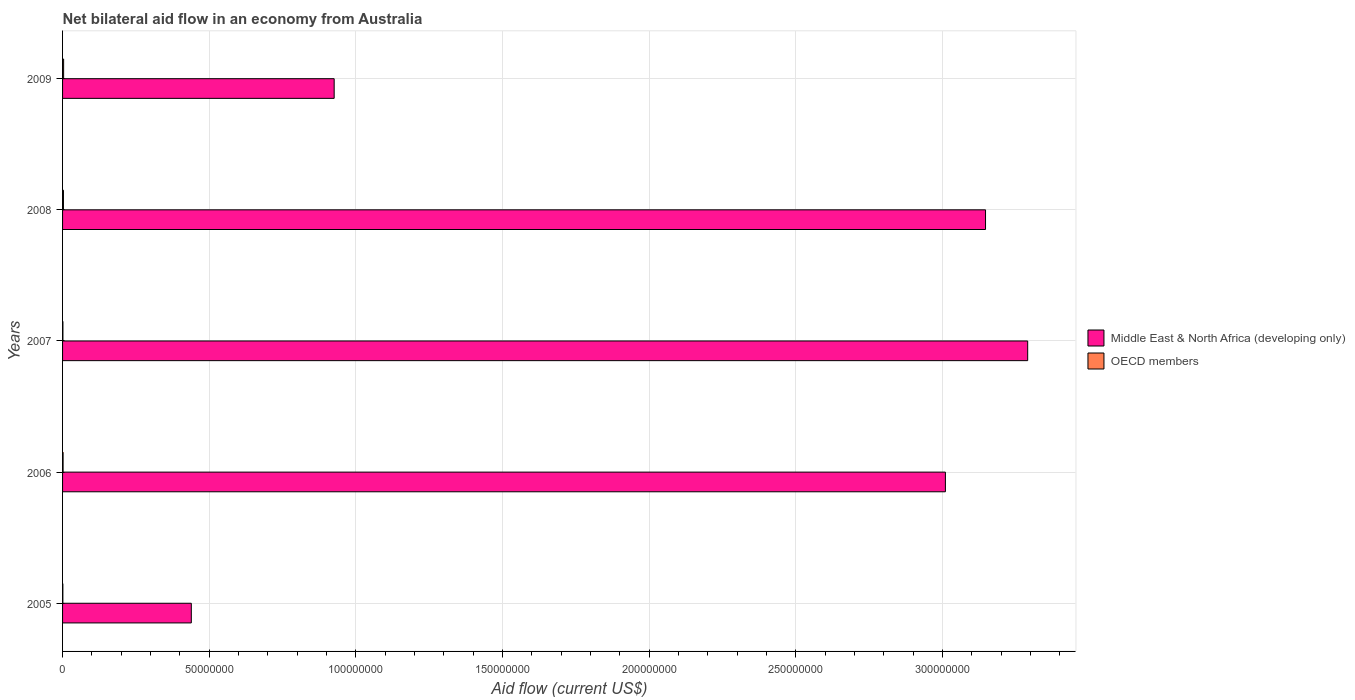Are the number of bars per tick equal to the number of legend labels?
Your response must be concise. Yes. Are the number of bars on each tick of the Y-axis equal?
Keep it short and to the point. Yes. In how many cases, is the number of bars for a given year not equal to the number of legend labels?
Your answer should be very brief. 0. What is the net bilateral aid flow in OECD members in 2005?
Keep it short and to the point. 1.00e+05. Across all years, what is the maximum net bilateral aid flow in Middle East & North Africa (developing only)?
Give a very brief answer. 3.29e+08. Across all years, what is the minimum net bilateral aid flow in OECD members?
Give a very brief answer. 1.00e+05. In which year was the net bilateral aid flow in OECD members minimum?
Offer a very short reply. 2005. What is the total net bilateral aid flow in Middle East & North Africa (developing only) in the graph?
Your response must be concise. 1.08e+09. What is the difference between the net bilateral aid flow in OECD members in 2008 and that in 2009?
Your answer should be compact. -6.00e+04. What is the difference between the net bilateral aid flow in Middle East & North Africa (developing only) in 2006 and the net bilateral aid flow in OECD members in 2009?
Provide a succinct answer. 3.01e+08. What is the average net bilateral aid flow in Middle East & North Africa (developing only) per year?
Make the answer very short. 2.16e+08. In the year 2007, what is the difference between the net bilateral aid flow in Middle East & North Africa (developing only) and net bilateral aid flow in OECD members?
Keep it short and to the point. 3.29e+08. In how many years, is the net bilateral aid flow in OECD members greater than 270000000 US$?
Provide a succinct answer. 0. What is the ratio of the net bilateral aid flow in Middle East & North Africa (developing only) in 2005 to that in 2008?
Offer a terse response. 0.14. What is the difference between the highest and the lowest net bilateral aid flow in OECD members?
Ensure brevity in your answer.  2.60e+05. What does the 1st bar from the top in 2005 represents?
Give a very brief answer. OECD members. What does the 1st bar from the bottom in 2008 represents?
Offer a very short reply. Middle East & North Africa (developing only). Are all the bars in the graph horizontal?
Give a very brief answer. Yes. What is the difference between two consecutive major ticks on the X-axis?
Ensure brevity in your answer.  5.00e+07. Are the values on the major ticks of X-axis written in scientific E-notation?
Give a very brief answer. No. Where does the legend appear in the graph?
Ensure brevity in your answer.  Center right. How are the legend labels stacked?
Your answer should be very brief. Vertical. What is the title of the graph?
Give a very brief answer. Net bilateral aid flow in an economy from Australia. Does "Fiji" appear as one of the legend labels in the graph?
Your response must be concise. No. What is the label or title of the Y-axis?
Offer a terse response. Years. What is the Aid flow (current US$) in Middle East & North Africa (developing only) in 2005?
Your response must be concise. 4.39e+07. What is the Aid flow (current US$) of Middle East & North Africa (developing only) in 2006?
Make the answer very short. 3.01e+08. What is the Aid flow (current US$) of Middle East & North Africa (developing only) in 2007?
Ensure brevity in your answer.  3.29e+08. What is the Aid flow (current US$) of Middle East & North Africa (developing only) in 2008?
Your answer should be compact. 3.15e+08. What is the Aid flow (current US$) in Middle East & North Africa (developing only) in 2009?
Make the answer very short. 9.26e+07. Across all years, what is the maximum Aid flow (current US$) in Middle East & North Africa (developing only)?
Provide a short and direct response. 3.29e+08. Across all years, what is the maximum Aid flow (current US$) in OECD members?
Offer a very short reply. 3.60e+05. Across all years, what is the minimum Aid flow (current US$) in Middle East & North Africa (developing only)?
Offer a very short reply. 4.39e+07. What is the total Aid flow (current US$) in Middle East & North Africa (developing only) in the graph?
Your answer should be compact. 1.08e+09. What is the total Aid flow (current US$) in OECD members in the graph?
Provide a succinct answer. 1.06e+06. What is the difference between the Aid flow (current US$) in Middle East & North Africa (developing only) in 2005 and that in 2006?
Offer a very short reply. -2.57e+08. What is the difference between the Aid flow (current US$) in OECD members in 2005 and that in 2006?
Provide a short and direct response. -8.00e+04. What is the difference between the Aid flow (current US$) in Middle East & North Africa (developing only) in 2005 and that in 2007?
Give a very brief answer. -2.85e+08. What is the difference between the Aid flow (current US$) in OECD members in 2005 and that in 2007?
Keep it short and to the point. -2.00e+04. What is the difference between the Aid flow (current US$) in Middle East & North Africa (developing only) in 2005 and that in 2008?
Offer a very short reply. -2.71e+08. What is the difference between the Aid flow (current US$) in OECD members in 2005 and that in 2008?
Offer a terse response. -2.00e+05. What is the difference between the Aid flow (current US$) in Middle East & North Africa (developing only) in 2005 and that in 2009?
Your answer should be very brief. -4.87e+07. What is the difference between the Aid flow (current US$) in Middle East & North Africa (developing only) in 2006 and that in 2007?
Offer a terse response. -2.80e+07. What is the difference between the Aid flow (current US$) in Middle East & North Africa (developing only) in 2006 and that in 2008?
Your response must be concise. -1.37e+07. What is the difference between the Aid flow (current US$) in OECD members in 2006 and that in 2008?
Give a very brief answer. -1.20e+05. What is the difference between the Aid flow (current US$) of Middle East & North Africa (developing only) in 2006 and that in 2009?
Your response must be concise. 2.08e+08. What is the difference between the Aid flow (current US$) of OECD members in 2006 and that in 2009?
Ensure brevity in your answer.  -1.80e+05. What is the difference between the Aid flow (current US$) of Middle East & North Africa (developing only) in 2007 and that in 2008?
Offer a terse response. 1.44e+07. What is the difference between the Aid flow (current US$) of Middle East & North Africa (developing only) in 2007 and that in 2009?
Your answer should be very brief. 2.36e+08. What is the difference between the Aid flow (current US$) of OECD members in 2007 and that in 2009?
Your answer should be compact. -2.40e+05. What is the difference between the Aid flow (current US$) of Middle East & North Africa (developing only) in 2008 and that in 2009?
Provide a short and direct response. 2.22e+08. What is the difference between the Aid flow (current US$) of OECD members in 2008 and that in 2009?
Give a very brief answer. -6.00e+04. What is the difference between the Aid flow (current US$) of Middle East & North Africa (developing only) in 2005 and the Aid flow (current US$) of OECD members in 2006?
Your answer should be very brief. 4.37e+07. What is the difference between the Aid flow (current US$) in Middle East & North Africa (developing only) in 2005 and the Aid flow (current US$) in OECD members in 2007?
Your answer should be very brief. 4.38e+07. What is the difference between the Aid flow (current US$) of Middle East & North Africa (developing only) in 2005 and the Aid flow (current US$) of OECD members in 2008?
Give a very brief answer. 4.36e+07. What is the difference between the Aid flow (current US$) in Middle East & North Africa (developing only) in 2005 and the Aid flow (current US$) in OECD members in 2009?
Offer a terse response. 4.35e+07. What is the difference between the Aid flow (current US$) of Middle East & North Africa (developing only) in 2006 and the Aid flow (current US$) of OECD members in 2007?
Keep it short and to the point. 3.01e+08. What is the difference between the Aid flow (current US$) in Middle East & North Africa (developing only) in 2006 and the Aid flow (current US$) in OECD members in 2008?
Provide a short and direct response. 3.01e+08. What is the difference between the Aid flow (current US$) in Middle East & North Africa (developing only) in 2006 and the Aid flow (current US$) in OECD members in 2009?
Give a very brief answer. 3.01e+08. What is the difference between the Aid flow (current US$) in Middle East & North Africa (developing only) in 2007 and the Aid flow (current US$) in OECD members in 2008?
Provide a succinct answer. 3.29e+08. What is the difference between the Aid flow (current US$) of Middle East & North Africa (developing only) in 2007 and the Aid flow (current US$) of OECD members in 2009?
Provide a short and direct response. 3.29e+08. What is the difference between the Aid flow (current US$) of Middle East & North Africa (developing only) in 2008 and the Aid flow (current US$) of OECD members in 2009?
Offer a terse response. 3.14e+08. What is the average Aid flow (current US$) in Middle East & North Africa (developing only) per year?
Your answer should be compact. 2.16e+08. What is the average Aid flow (current US$) of OECD members per year?
Your answer should be compact. 2.12e+05. In the year 2005, what is the difference between the Aid flow (current US$) of Middle East & North Africa (developing only) and Aid flow (current US$) of OECD members?
Keep it short and to the point. 4.38e+07. In the year 2006, what is the difference between the Aid flow (current US$) in Middle East & North Africa (developing only) and Aid flow (current US$) in OECD members?
Your answer should be compact. 3.01e+08. In the year 2007, what is the difference between the Aid flow (current US$) of Middle East & North Africa (developing only) and Aid flow (current US$) of OECD members?
Your response must be concise. 3.29e+08. In the year 2008, what is the difference between the Aid flow (current US$) in Middle East & North Africa (developing only) and Aid flow (current US$) in OECD members?
Your answer should be very brief. 3.14e+08. In the year 2009, what is the difference between the Aid flow (current US$) of Middle East & North Africa (developing only) and Aid flow (current US$) of OECD members?
Keep it short and to the point. 9.22e+07. What is the ratio of the Aid flow (current US$) of Middle East & North Africa (developing only) in 2005 to that in 2006?
Provide a succinct answer. 0.15. What is the ratio of the Aid flow (current US$) of OECD members in 2005 to that in 2006?
Keep it short and to the point. 0.56. What is the ratio of the Aid flow (current US$) of Middle East & North Africa (developing only) in 2005 to that in 2007?
Provide a succinct answer. 0.13. What is the ratio of the Aid flow (current US$) in Middle East & North Africa (developing only) in 2005 to that in 2008?
Provide a short and direct response. 0.14. What is the ratio of the Aid flow (current US$) of OECD members in 2005 to that in 2008?
Your response must be concise. 0.33. What is the ratio of the Aid flow (current US$) in Middle East & North Africa (developing only) in 2005 to that in 2009?
Offer a terse response. 0.47. What is the ratio of the Aid flow (current US$) in OECD members in 2005 to that in 2009?
Keep it short and to the point. 0.28. What is the ratio of the Aid flow (current US$) in Middle East & North Africa (developing only) in 2006 to that in 2007?
Make the answer very short. 0.91. What is the ratio of the Aid flow (current US$) of OECD members in 2006 to that in 2007?
Your answer should be compact. 1.5. What is the ratio of the Aid flow (current US$) of Middle East & North Africa (developing only) in 2006 to that in 2008?
Offer a terse response. 0.96. What is the ratio of the Aid flow (current US$) of OECD members in 2006 to that in 2008?
Your answer should be very brief. 0.6. What is the ratio of the Aid flow (current US$) in Middle East & North Africa (developing only) in 2006 to that in 2009?
Provide a short and direct response. 3.25. What is the ratio of the Aid flow (current US$) of Middle East & North Africa (developing only) in 2007 to that in 2008?
Your answer should be compact. 1.05. What is the ratio of the Aid flow (current US$) of Middle East & North Africa (developing only) in 2007 to that in 2009?
Ensure brevity in your answer.  3.55. What is the ratio of the Aid flow (current US$) of Middle East & North Africa (developing only) in 2008 to that in 2009?
Provide a short and direct response. 3.4. What is the ratio of the Aid flow (current US$) in OECD members in 2008 to that in 2009?
Your answer should be very brief. 0.83. What is the difference between the highest and the second highest Aid flow (current US$) in Middle East & North Africa (developing only)?
Ensure brevity in your answer.  1.44e+07. What is the difference between the highest and the second highest Aid flow (current US$) in OECD members?
Your response must be concise. 6.00e+04. What is the difference between the highest and the lowest Aid flow (current US$) in Middle East & North Africa (developing only)?
Your answer should be very brief. 2.85e+08. 